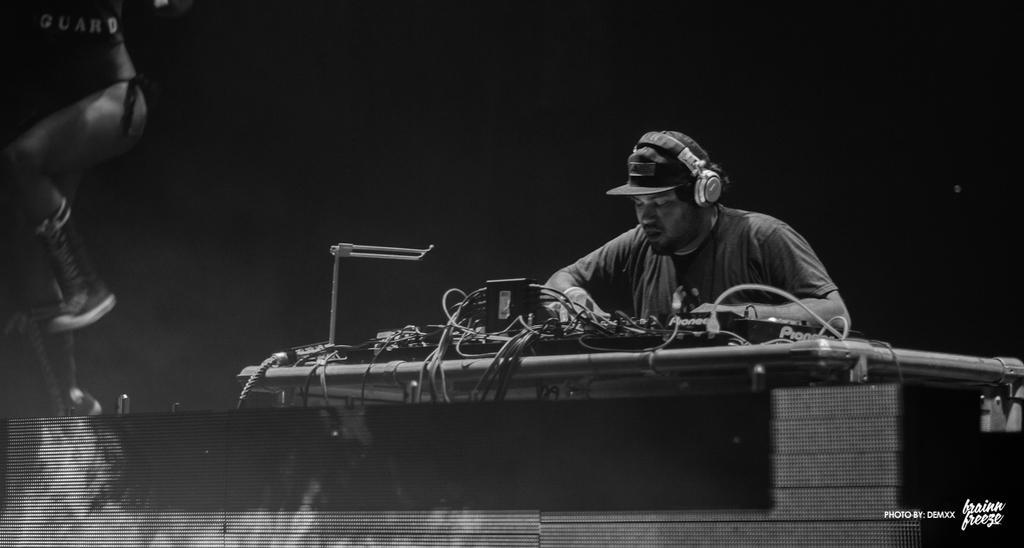Describe this image in one or two sentences. In this image in the center there is a person wearing a headset and black colour hat. In front of the person on the table, there are wires and there is a lamp. On the left side there is a person and in the front there is an object which is black in colour. 